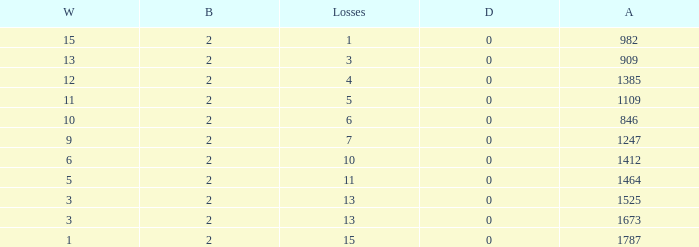What is the number listed under against when there were less than 13 losses and less than 2 byes? 0.0. 